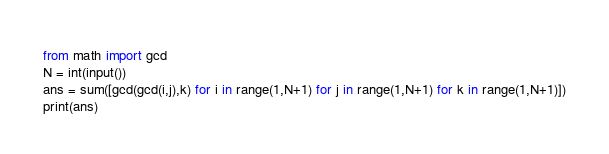<code> <loc_0><loc_0><loc_500><loc_500><_Python_>from math import gcd
N = int(input())
ans = sum([gcd(gcd(i,j),k) for i in range(1,N+1) for j in range(1,N+1) for k in range(1,N+1)])
print(ans)
</code> 